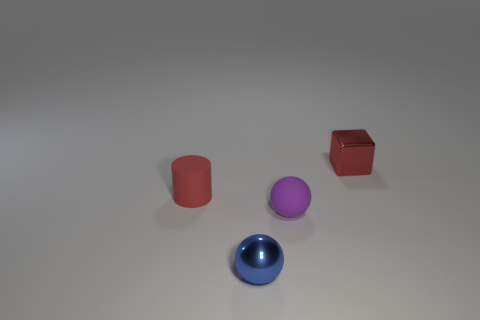There is a cylinder that is the same color as the metal cube; what material is it?
Offer a very short reply. Rubber. How many cyan things are matte objects or cylinders?
Offer a terse response. 0. There is a metal object to the left of the red metallic block; is it the same shape as the tiny matte thing that is in front of the small red matte cylinder?
Offer a very short reply. Yes. How many other objects are there of the same material as the tiny blue thing?
Give a very brief answer. 1. Is there a ball on the left side of the red object that is in front of the small metallic block on the right side of the tiny metallic sphere?
Give a very brief answer. No. Is the material of the block the same as the tiny purple thing?
Keep it short and to the point. No. Is there anything else that is the same shape as the small blue object?
Provide a short and direct response. Yes. What is the material of the small sphere behind the small metallic thing that is to the left of the block?
Your answer should be very brief. Rubber. Are there the same number of red shiny things and small green matte things?
Your response must be concise. No. What is the size of the sphere that is in front of the purple matte sphere?
Your response must be concise. Small. 